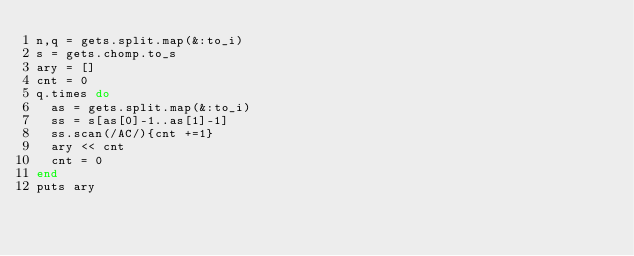Convert code to text. <code><loc_0><loc_0><loc_500><loc_500><_Ruby_>n,q = gets.split.map(&:to_i)
s = gets.chomp.to_s
ary = []
cnt = 0
q.times do
  as = gets.split.map(&:to_i)
  ss = s[as[0]-1..as[1]-1]
  ss.scan(/AC/){cnt +=1}
  ary << cnt
  cnt = 0
end
puts ary</code> 